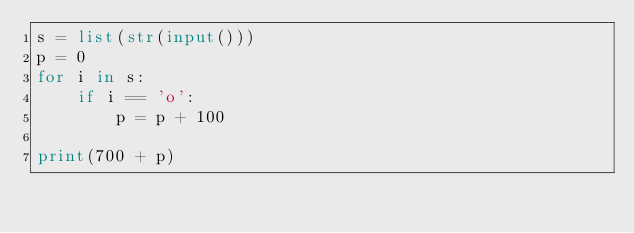<code> <loc_0><loc_0><loc_500><loc_500><_Python_>s = list(str(input()))
p = 0
for i in s:
    if i == 'o':
        p = p + 100
        
print(700 + p)</code> 